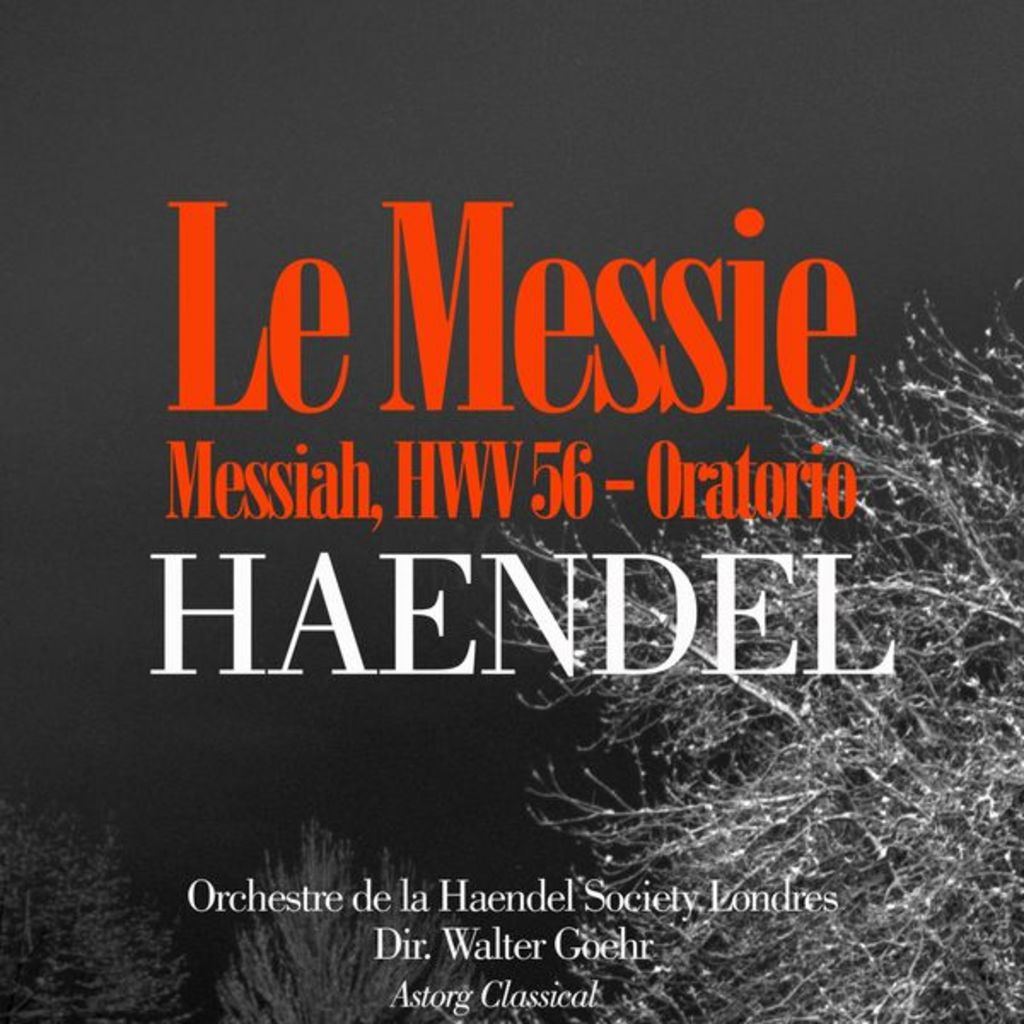Who were the performers listed and what is notable about their performance? The poster lists the Orchestre de la Haendel Society, directed by Walter Goehr. This ensemble is known for historically informed performances of Baroque music which aim to closely replicate the music’s original sound using period instruments and techniques. 